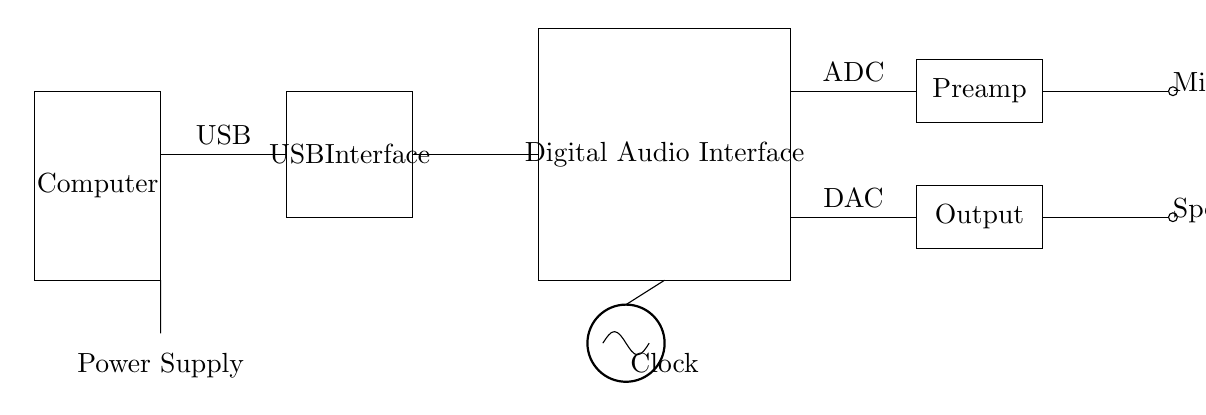What components are included in the circuit? The circuit diagram includes a computer, USB interface, digital audio interface, ADC, DAC, preamp, output, microphone, speaker, clock, and power supply. Each component is represented in the drawing, depicting their functions in a digital audio recording setup.
Answer: computer, USB interface, digital audio interface, ADC, DAC, preamp, output, microphone, speaker, clock, power supply What is the role of the ADC in this circuit? The ADC converts analog signals from the microphone into digital data for processing by the computer. This is crucial in digital audio interfaces, as it allows for high-quality recording and manipulation of audio signals.
Answer: Converts analog to digital What is powering the entire circuit? The circuit is powered by a battery, which provides the necessary voltage for the various components to function properly, including the digital audio interface and other signal processing elements.
Answer: Power supply How many main functional blocks are visible in the diagram? There are five main functional blocks in the diagram: the USB interface, the digital audio interface, the ADC, the DAC, and the preamp/output sections. Each block serves a specific purpose in managing audio signals.
Answer: Five Which component is directly connected to the microphone? The preamp is the component that connects directly to the microphone, amplifying the analog signal before it is converted by the ADC into digital format. This step is essential for ensuring that the audio signal is strong enough for processing.
Answer: Preamp What signals are sent to the speaker? The DAC sends the digital signal converted back into an analog signal to the speaker for playback. This involves reversing the conversion process, allowing users to hear the audio output from the computer.
Answer: Output 